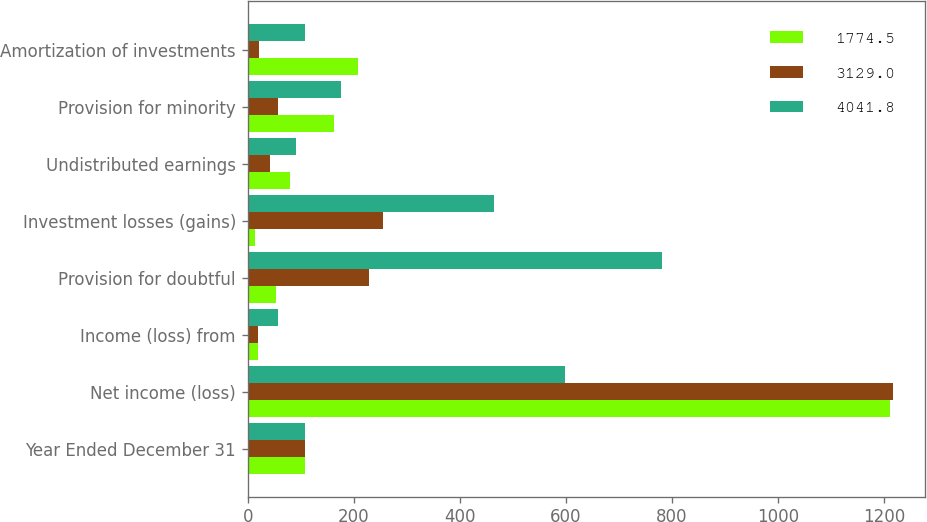Convert chart to OTSL. <chart><loc_0><loc_0><loc_500><loc_500><stacked_bar_chart><ecel><fcel>Year Ended December 31<fcel>Net income (loss)<fcel>Income (loss) from<fcel>Provision for doubtful<fcel>Investment losses (gains)<fcel>Undistributed earnings<fcel>Provision for minority<fcel>Amortization of investments<nl><fcel>1774.5<fcel>108.6<fcel>1211.6<fcel>18.7<fcel>52.7<fcel>13.2<fcel>79.2<fcel>163.2<fcel>207.6<nl><fcel>3129<fcel>108.6<fcel>1215.8<fcel>19.5<fcel>228.2<fcel>256<fcel>42.2<fcel>57.3<fcel>21.5<nl><fcel>4041.8<fcel>108.6<fcel>597.2<fcel>56.8<fcel>780.9<fcel>464.1<fcel>91.7<fcel>176.5<fcel>108.6<nl></chart> 